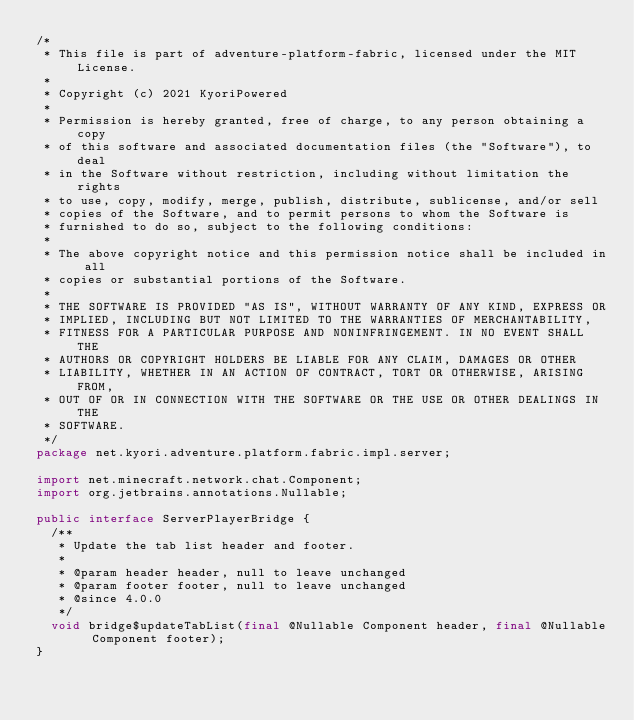Convert code to text. <code><loc_0><loc_0><loc_500><loc_500><_Java_>/*
 * This file is part of adventure-platform-fabric, licensed under the MIT License.
 *
 * Copyright (c) 2021 KyoriPowered
 *
 * Permission is hereby granted, free of charge, to any person obtaining a copy
 * of this software and associated documentation files (the "Software"), to deal
 * in the Software without restriction, including without limitation the rights
 * to use, copy, modify, merge, publish, distribute, sublicense, and/or sell
 * copies of the Software, and to permit persons to whom the Software is
 * furnished to do so, subject to the following conditions:
 *
 * The above copyright notice and this permission notice shall be included in all
 * copies or substantial portions of the Software.
 *
 * THE SOFTWARE IS PROVIDED "AS IS", WITHOUT WARRANTY OF ANY KIND, EXPRESS OR
 * IMPLIED, INCLUDING BUT NOT LIMITED TO THE WARRANTIES OF MERCHANTABILITY,
 * FITNESS FOR A PARTICULAR PURPOSE AND NONINFRINGEMENT. IN NO EVENT SHALL THE
 * AUTHORS OR COPYRIGHT HOLDERS BE LIABLE FOR ANY CLAIM, DAMAGES OR OTHER
 * LIABILITY, WHETHER IN AN ACTION OF CONTRACT, TORT OR OTHERWISE, ARISING FROM,
 * OUT OF OR IN CONNECTION WITH THE SOFTWARE OR THE USE OR OTHER DEALINGS IN THE
 * SOFTWARE.
 */
package net.kyori.adventure.platform.fabric.impl.server;

import net.minecraft.network.chat.Component;
import org.jetbrains.annotations.Nullable;

public interface ServerPlayerBridge {
  /**
   * Update the tab list header and footer.
   *
   * @param header header, null to leave unchanged
   * @param footer footer, null to leave unchanged
   * @since 4.0.0
   */
  void bridge$updateTabList(final @Nullable Component header, final @Nullable Component footer);
}
</code> 